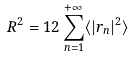Convert formula to latex. <formula><loc_0><loc_0><loc_500><loc_500>R ^ { 2 } = 1 2 \sum _ { n = 1 } ^ { + \infty } \langle | { r } _ { n } | ^ { 2 } \rangle</formula> 